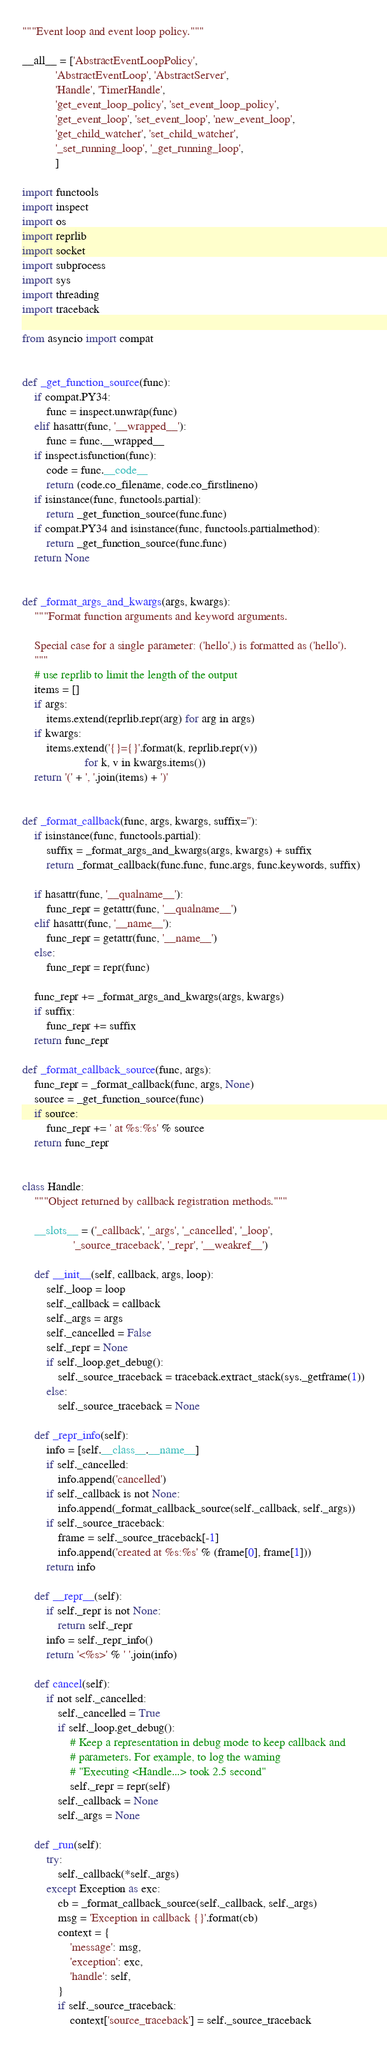<code> <loc_0><loc_0><loc_500><loc_500><_Python_>"""Event loop and event loop policy."""

__all__ = ['AbstractEventLoopPolicy',
           'AbstractEventLoop', 'AbstractServer',
           'Handle', 'TimerHandle',
           'get_event_loop_policy', 'set_event_loop_policy',
           'get_event_loop', 'set_event_loop', 'new_event_loop',
           'get_child_watcher', 'set_child_watcher',
           '_set_running_loop', '_get_running_loop',
           ]

import functools
import inspect
import os
import reprlib
import socket
import subprocess
import sys
import threading
import traceback

from asyncio import compat


def _get_function_source(func):
    if compat.PY34:
        func = inspect.unwrap(func)
    elif hasattr(func, '__wrapped__'):
        func = func.__wrapped__
    if inspect.isfunction(func):
        code = func.__code__
        return (code.co_filename, code.co_firstlineno)
    if isinstance(func, functools.partial):
        return _get_function_source(func.func)
    if compat.PY34 and isinstance(func, functools.partialmethod):
        return _get_function_source(func.func)
    return None


def _format_args_and_kwargs(args, kwargs):
    """Format function arguments and keyword arguments.

    Special case for a single parameter: ('hello',) is formatted as ('hello').
    """
    # use reprlib to limit the length of the output
    items = []
    if args:
        items.extend(reprlib.repr(arg) for arg in args)
    if kwargs:
        items.extend('{}={}'.format(k, reprlib.repr(v))
                     for k, v in kwargs.items())
    return '(' + ', '.join(items) + ')'


def _format_callback(func, args, kwargs, suffix=''):
    if isinstance(func, functools.partial):
        suffix = _format_args_and_kwargs(args, kwargs) + suffix
        return _format_callback(func.func, func.args, func.keywords, suffix)

    if hasattr(func, '__qualname__'):
        func_repr = getattr(func, '__qualname__')
    elif hasattr(func, '__name__'):
        func_repr = getattr(func, '__name__')
    else:
        func_repr = repr(func)

    func_repr += _format_args_and_kwargs(args, kwargs)
    if suffix:
        func_repr += suffix
    return func_repr

def _format_callback_source(func, args):
    func_repr = _format_callback(func, args, None)
    source = _get_function_source(func)
    if source:
        func_repr += ' at %s:%s' % source
    return func_repr


class Handle:
    """Object returned by callback registration methods."""

    __slots__ = ('_callback', '_args', '_cancelled', '_loop',
                 '_source_traceback', '_repr', '__weakref__')

    def __init__(self, callback, args, loop):
        self._loop = loop
        self._callback = callback
        self._args = args
        self._cancelled = False
        self._repr = None
        if self._loop.get_debug():
            self._source_traceback = traceback.extract_stack(sys._getframe(1))
        else:
            self._source_traceback = None

    def _repr_info(self):
        info = [self.__class__.__name__]
        if self._cancelled:
            info.append('cancelled')
        if self._callback is not None:
            info.append(_format_callback_source(self._callback, self._args))
        if self._source_traceback:
            frame = self._source_traceback[-1]
            info.append('created at %s:%s' % (frame[0], frame[1]))
        return info

    def __repr__(self):
        if self._repr is not None:
            return self._repr
        info = self._repr_info()
        return '<%s>' % ' '.join(info)

    def cancel(self):
        if not self._cancelled:
            self._cancelled = True
            if self._loop.get_debug():
                # Keep a representation in debug mode to keep callback and
                # parameters. For example, to log the warning
                # "Executing <Handle...> took 2.5 second"
                self._repr = repr(self)
            self._callback = None
            self._args = None

    def _run(self):
        try:
            self._callback(*self._args)
        except Exception as exc:
            cb = _format_callback_source(self._callback, self._args)
            msg = 'Exception in callback {}'.format(cb)
            context = {
                'message': msg,
                'exception': exc,
                'handle': self,
            }
            if self._source_traceback:
                context['source_traceback'] = self._source_traceback</code> 